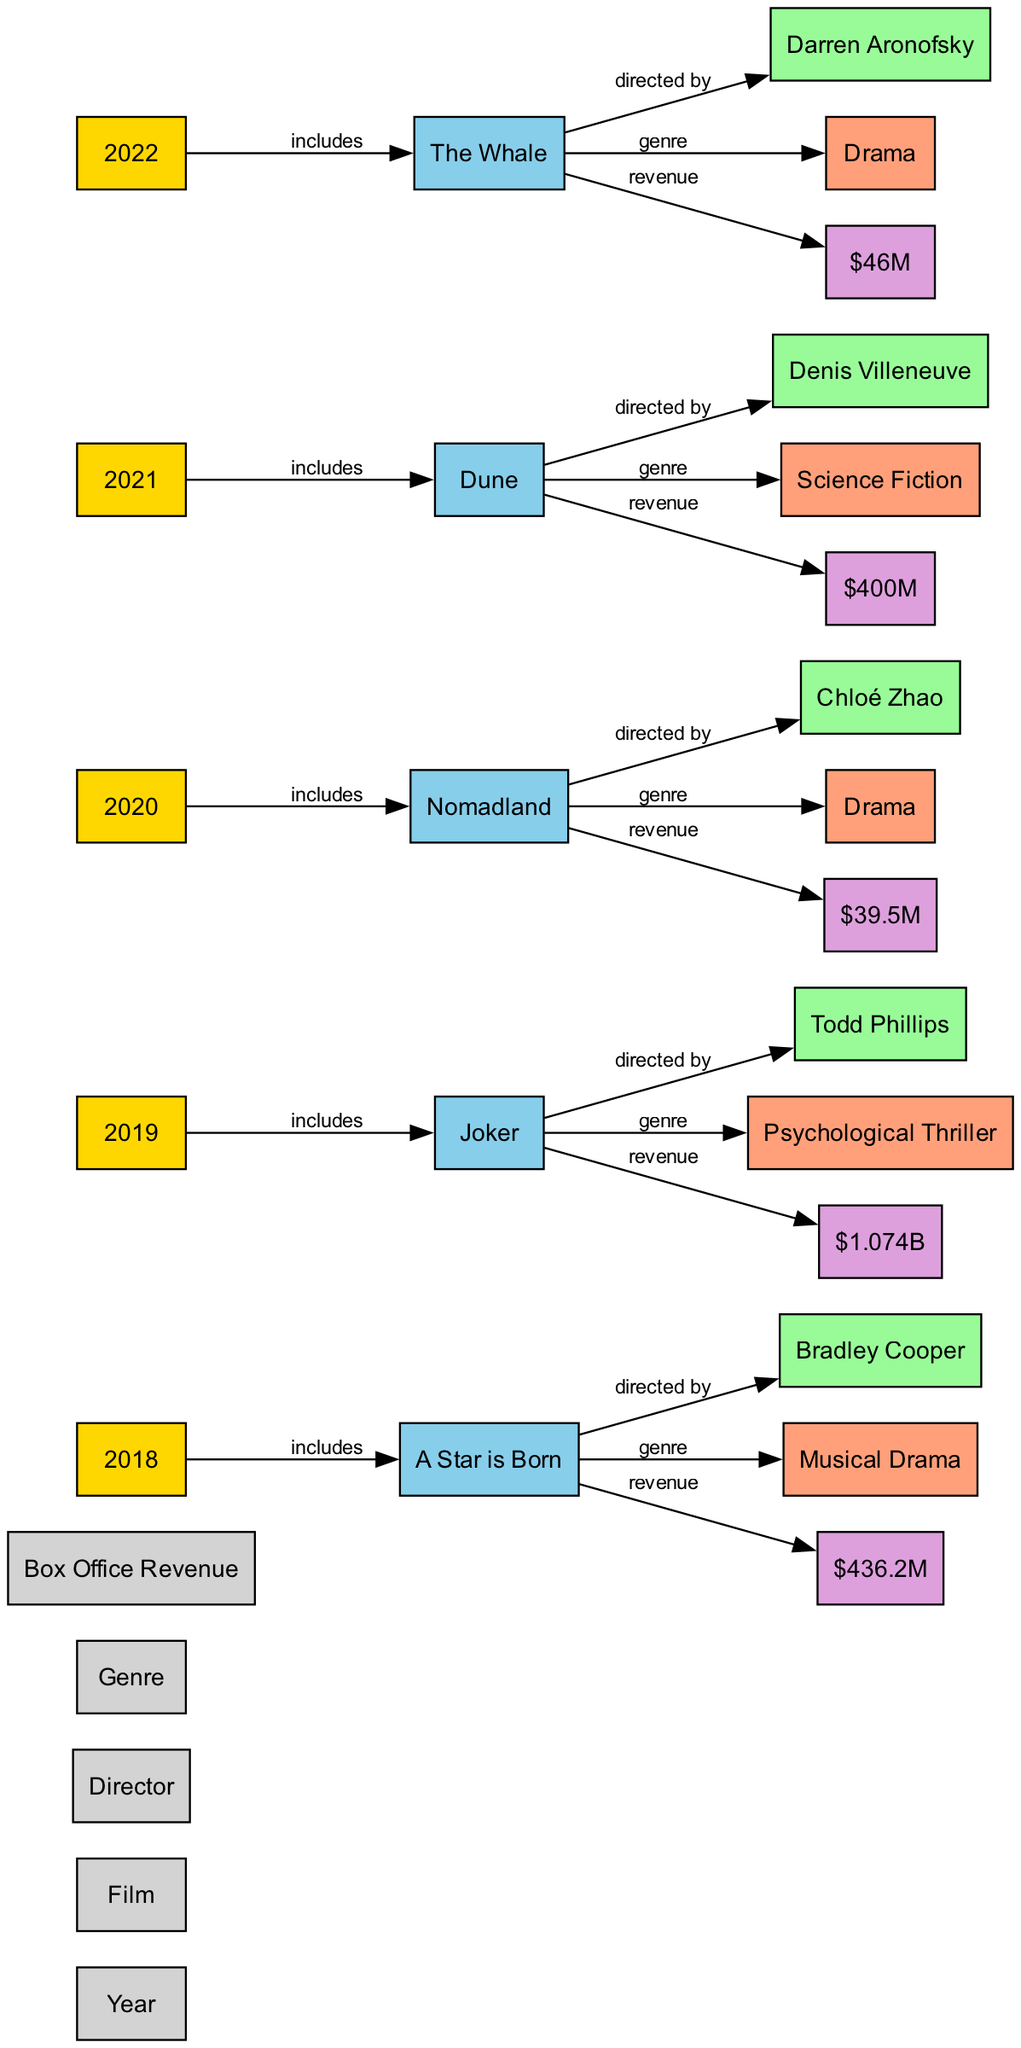What film had the highest box office revenue in 2019? The diagram indicates that "Joker" had the highest box office revenue in 2019, with a revenue of "$1.074B." This is shown in the node for the year 2019 where it includes the film "Joker" and its corresponding revenue.
Answer: Joker Who directed "A Star is Born"? According to the diagram, "A Star is Born" was directed by Bradley Cooper. This can be seen in the connection between the film and the director node.
Answer: Bradley Cooper Which genre does "Nomadland" belong to? The diagram shows that "Nomadland" is categorized under the "Drama" genre. This relationship is represented in the diagram where "Nomadland" connects to the genre node labeled "Drama."
Answer: Drama What was the box office revenue for "The Whale"? The diagram clearly shows that "The Whale" had a box office revenue of "$46M." This information is linked directly to the film in the year 2022.
Answer: $46M In terms of box office revenue, which film from 2021 performed better, "Dune" or "Nomadland"? Looking at the revenues, "Dune" made "$400M" and "Nomadland" made "$39.5M." Thus, "Dune" performed better in terms of box office revenue. This requires comparing the revenues linked to each film's respective node in the diagram.
Answer: Dune How many films are represented in the diagram? The diagram includes five films: "A Star is Born," "Joker," "Nomadland," "Dune," and "The Whale." By counting the individual film nodes connected to their respective years, we arrive at this total.
Answer: 5 What is the genre of the film directed by Denis Villeneuve? The diagram assigns the genre "Science Fiction" to the film "Dune," which is directed by Denis Villeneuve. This relationship can be traced via the edges connecting the film node to its genre node.
Answer: Science Fiction What was the box office revenue in 2018? The box office revenue in 2018 was "$436.2M" as shown in the node for the year 2018, directly linked to the film "A Star is Born."
Answer: $436.2M Which film had the lowest box office revenue from 2018 to 2022? "Nomadland" had the lowest box office revenue at "$39.5M," which is the smallest value compared to others listed for the years 2018 through 2022. This answer is derived by comparing the revenues displayed for each film in their respective years.
Answer: Nomadland 